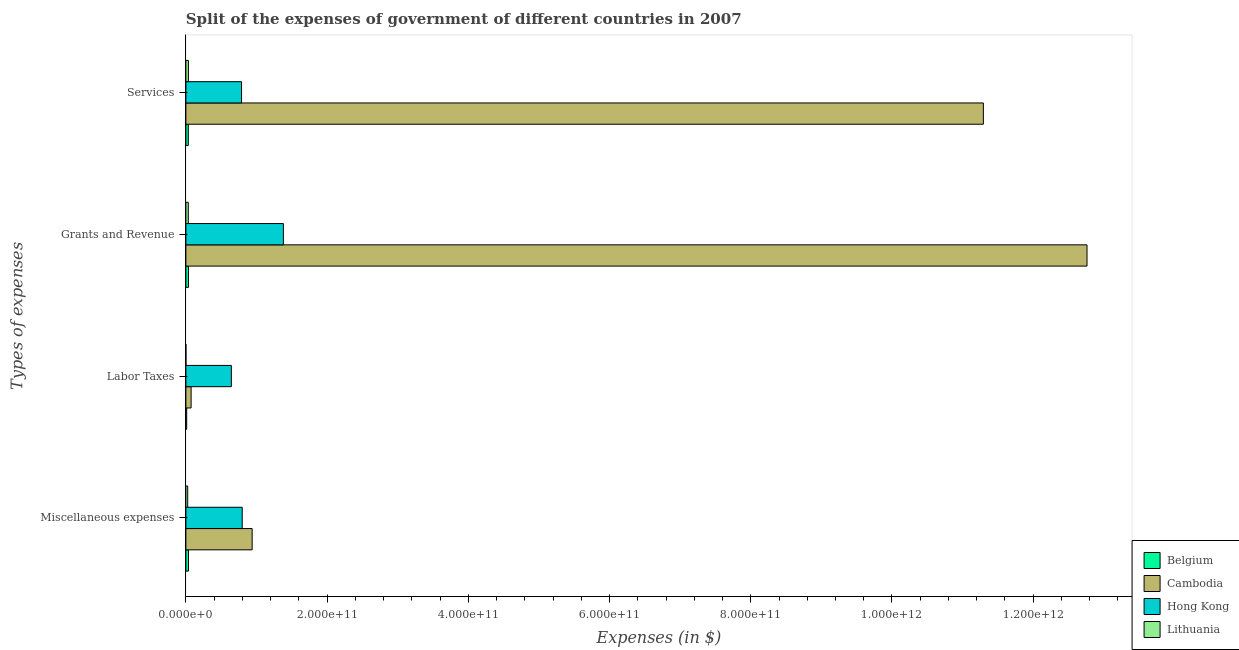How many different coloured bars are there?
Your response must be concise. 4. How many groups of bars are there?
Offer a terse response. 4. Are the number of bars per tick equal to the number of legend labels?
Provide a succinct answer. Yes. Are the number of bars on each tick of the Y-axis equal?
Ensure brevity in your answer.  Yes. How many bars are there on the 1st tick from the bottom?
Keep it short and to the point. 4. What is the label of the 4th group of bars from the top?
Offer a terse response. Miscellaneous expenses. What is the amount spent on services in Belgium?
Keep it short and to the point. 3.44e+09. Across all countries, what is the maximum amount spent on grants and revenue?
Your answer should be compact. 1.28e+12. Across all countries, what is the minimum amount spent on grants and revenue?
Give a very brief answer. 3.42e+09. In which country was the amount spent on miscellaneous expenses maximum?
Keep it short and to the point. Cambodia. What is the total amount spent on miscellaneous expenses in the graph?
Provide a short and direct response. 1.80e+11. What is the difference between the amount spent on labor taxes in Lithuania and that in Cambodia?
Offer a terse response. -7.38e+09. What is the difference between the amount spent on miscellaneous expenses in Lithuania and the amount spent on labor taxes in Hong Kong?
Keep it short and to the point. -6.18e+1. What is the average amount spent on services per country?
Give a very brief answer. 3.04e+11. What is the difference between the amount spent on services and amount spent on grants and revenue in Hong Kong?
Your answer should be compact. -5.93e+1. In how many countries, is the amount spent on services greater than 960000000000 $?
Provide a succinct answer. 1. What is the ratio of the amount spent on miscellaneous expenses in Cambodia to that in Belgium?
Offer a very short reply. 25.39. What is the difference between the highest and the second highest amount spent on miscellaneous expenses?
Your answer should be very brief. 1.41e+1. What is the difference between the highest and the lowest amount spent on labor taxes?
Your answer should be very brief. 6.44e+1. Is the sum of the amount spent on grants and revenue in Lithuania and Hong Kong greater than the maximum amount spent on services across all countries?
Keep it short and to the point. No. How many bars are there?
Your answer should be compact. 16. Are all the bars in the graph horizontal?
Provide a succinct answer. Yes. How many countries are there in the graph?
Your answer should be compact. 4. What is the difference between two consecutive major ticks on the X-axis?
Your response must be concise. 2.00e+11. Does the graph contain grids?
Provide a succinct answer. No. How many legend labels are there?
Your response must be concise. 4. What is the title of the graph?
Your response must be concise. Split of the expenses of government of different countries in 2007. Does "Turks and Caicos Islands" appear as one of the legend labels in the graph?
Make the answer very short. No. What is the label or title of the X-axis?
Give a very brief answer. Expenses (in $). What is the label or title of the Y-axis?
Ensure brevity in your answer.  Types of expenses. What is the Expenses (in $) in Belgium in Miscellaneous expenses?
Your response must be concise. 3.70e+09. What is the Expenses (in $) in Cambodia in Miscellaneous expenses?
Your answer should be compact. 9.39e+1. What is the Expenses (in $) in Hong Kong in Miscellaneous expenses?
Your answer should be compact. 7.98e+1. What is the Expenses (in $) of Lithuania in Miscellaneous expenses?
Provide a short and direct response. 2.58e+09. What is the Expenses (in $) in Belgium in Labor Taxes?
Keep it short and to the point. 1.15e+09. What is the Expenses (in $) in Cambodia in Labor Taxes?
Give a very brief answer. 7.42e+09. What is the Expenses (in $) of Hong Kong in Labor Taxes?
Make the answer very short. 6.44e+1. What is the Expenses (in $) in Lithuania in Labor Taxes?
Your answer should be compact. 3.97e+07. What is the Expenses (in $) in Belgium in Grants and Revenue?
Your answer should be compact. 3.64e+09. What is the Expenses (in $) in Cambodia in Grants and Revenue?
Your answer should be very brief. 1.28e+12. What is the Expenses (in $) in Hong Kong in Grants and Revenue?
Offer a terse response. 1.38e+11. What is the Expenses (in $) in Lithuania in Grants and Revenue?
Your answer should be very brief. 3.42e+09. What is the Expenses (in $) of Belgium in Services?
Your answer should be compact. 3.44e+09. What is the Expenses (in $) in Cambodia in Services?
Make the answer very short. 1.13e+12. What is the Expenses (in $) in Hong Kong in Services?
Provide a succinct answer. 7.88e+1. What is the Expenses (in $) of Lithuania in Services?
Provide a succinct answer. 3.58e+09. Across all Types of expenses, what is the maximum Expenses (in $) in Belgium?
Your response must be concise. 3.70e+09. Across all Types of expenses, what is the maximum Expenses (in $) of Cambodia?
Make the answer very short. 1.28e+12. Across all Types of expenses, what is the maximum Expenses (in $) of Hong Kong?
Ensure brevity in your answer.  1.38e+11. Across all Types of expenses, what is the maximum Expenses (in $) of Lithuania?
Ensure brevity in your answer.  3.58e+09. Across all Types of expenses, what is the minimum Expenses (in $) of Belgium?
Offer a terse response. 1.15e+09. Across all Types of expenses, what is the minimum Expenses (in $) of Cambodia?
Provide a succinct answer. 7.42e+09. Across all Types of expenses, what is the minimum Expenses (in $) of Hong Kong?
Your answer should be compact. 6.44e+1. Across all Types of expenses, what is the minimum Expenses (in $) in Lithuania?
Your answer should be very brief. 3.97e+07. What is the total Expenses (in $) of Belgium in the graph?
Keep it short and to the point. 1.19e+1. What is the total Expenses (in $) in Cambodia in the graph?
Your answer should be compact. 2.51e+12. What is the total Expenses (in $) of Hong Kong in the graph?
Make the answer very short. 3.61e+11. What is the total Expenses (in $) in Lithuania in the graph?
Provide a short and direct response. 9.62e+09. What is the difference between the Expenses (in $) of Belgium in Miscellaneous expenses and that in Labor Taxes?
Keep it short and to the point. 2.54e+09. What is the difference between the Expenses (in $) of Cambodia in Miscellaneous expenses and that in Labor Taxes?
Ensure brevity in your answer.  8.64e+1. What is the difference between the Expenses (in $) of Hong Kong in Miscellaneous expenses and that in Labor Taxes?
Your answer should be very brief. 1.54e+1. What is the difference between the Expenses (in $) in Lithuania in Miscellaneous expenses and that in Labor Taxes?
Offer a very short reply. 2.54e+09. What is the difference between the Expenses (in $) in Belgium in Miscellaneous expenses and that in Grants and Revenue?
Ensure brevity in your answer.  5.42e+07. What is the difference between the Expenses (in $) in Cambodia in Miscellaneous expenses and that in Grants and Revenue?
Provide a succinct answer. -1.18e+12. What is the difference between the Expenses (in $) in Hong Kong in Miscellaneous expenses and that in Grants and Revenue?
Give a very brief answer. -5.83e+1. What is the difference between the Expenses (in $) of Lithuania in Miscellaneous expenses and that in Grants and Revenue?
Make the answer very short. -8.37e+08. What is the difference between the Expenses (in $) in Belgium in Miscellaneous expenses and that in Services?
Provide a short and direct response. 2.58e+08. What is the difference between the Expenses (in $) of Cambodia in Miscellaneous expenses and that in Services?
Your answer should be very brief. -1.04e+12. What is the difference between the Expenses (in $) in Hong Kong in Miscellaneous expenses and that in Services?
Provide a short and direct response. 9.52e+08. What is the difference between the Expenses (in $) of Lithuania in Miscellaneous expenses and that in Services?
Your answer should be very brief. -9.99e+08. What is the difference between the Expenses (in $) of Belgium in Labor Taxes and that in Grants and Revenue?
Ensure brevity in your answer.  -2.49e+09. What is the difference between the Expenses (in $) of Cambodia in Labor Taxes and that in Grants and Revenue?
Your response must be concise. -1.27e+12. What is the difference between the Expenses (in $) in Hong Kong in Labor Taxes and that in Grants and Revenue?
Your response must be concise. -7.37e+1. What is the difference between the Expenses (in $) of Lithuania in Labor Taxes and that in Grants and Revenue?
Offer a very short reply. -3.38e+09. What is the difference between the Expenses (in $) in Belgium in Labor Taxes and that in Services?
Provide a succinct answer. -2.28e+09. What is the difference between the Expenses (in $) in Cambodia in Labor Taxes and that in Services?
Ensure brevity in your answer.  -1.12e+12. What is the difference between the Expenses (in $) in Hong Kong in Labor Taxes and that in Services?
Keep it short and to the point. -1.44e+1. What is the difference between the Expenses (in $) in Lithuania in Labor Taxes and that in Services?
Your response must be concise. -3.54e+09. What is the difference between the Expenses (in $) of Belgium in Grants and Revenue and that in Services?
Your answer should be very brief. 2.04e+08. What is the difference between the Expenses (in $) of Cambodia in Grants and Revenue and that in Services?
Provide a short and direct response. 1.47e+11. What is the difference between the Expenses (in $) of Hong Kong in Grants and Revenue and that in Services?
Keep it short and to the point. 5.93e+1. What is the difference between the Expenses (in $) of Lithuania in Grants and Revenue and that in Services?
Ensure brevity in your answer.  -1.62e+08. What is the difference between the Expenses (in $) of Belgium in Miscellaneous expenses and the Expenses (in $) of Cambodia in Labor Taxes?
Provide a short and direct response. -3.72e+09. What is the difference between the Expenses (in $) of Belgium in Miscellaneous expenses and the Expenses (in $) of Hong Kong in Labor Taxes?
Make the answer very short. -6.07e+1. What is the difference between the Expenses (in $) in Belgium in Miscellaneous expenses and the Expenses (in $) in Lithuania in Labor Taxes?
Keep it short and to the point. 3.66e+09. What is the difference between the Expenses (in $) of Cambodia in Miscellaneous expenses and the Expenses (in $) of Hong Kong in Labor Taxes?
Keep it short and to the point. 2.95e+1. What is the difference between the Expenses (in $) of Cambodia in Miscellaneous expenses and the Expenses (in $) of Lithuania in Labor Taxes?
Keep it short and to the point. 9.38e+1. What is the difference between the Expenses (in $) of Hong Kong in Miscellaneous expenses and the Expenses (in $) of Lithuania in Labor Taxes?
Make the answer very short. 7.97e+1. What is the difference between the Expenses (in $) of Belgium in Miscellaneous expenses and the Expenses (in $) of Cambodia in Grants and Revenue?
Offer a very short reply. -1.27e+12. What is the difference between the Expenses (in $) of Belgium in Miscellaneous expenses and the Expenses (in $) of Hong Kong in Grants and Revenue?
Provide a succinct answer. -1.34e+11. What is the difference between the Expenses (in $) in Belgium in Miscellaneous expenses and the Expenses (in $) in Lithuania in Grants and Revenue?
Provide a short and direct response. 2.77e+08. What is the difference between the Expenses (in $) in Cambodia in Miscellaneous expenses and the Expenses (in $) in Hong Kong in Grants and Revenue?
Your response must be concise. -4.42e+1. What is the difference between the Expenses (in $) in Cambodia in Miscellaneous expenses and the Expenses (in $) in Lithuania in Grants and Revenue?
Your response must be concise. 9.04e+1. What is the difference between the Expenses (in $) in Hong Kong in Miscellaneous expenses and the Expenses (in $) in Lithuania in Grants and Revenue?
Ensure brevity in your answer.  7.64e+1. What is the difference between the Expenses (in $) in Belgium in Miscellaneous expenses and the Expenses (in $) in Cambodia in Services?
Offer a terse response. -1.13e+12. What is the difference between the Expenses (in $) of Belgium in Miscellaneous expenses and the Expenses (in $) of Hong Kong in Services?
Keep it short and to the point. -7.51e+1. What is the difference between the Expenses (in $) in Belgium in Miscellaneous expenses and the Expenses (in $) in Lithuania in Services?
Keep it short and to the point. 1.14e+08. What is the difference between the Expenses (in $) in Cambodia in Miscellaneous expenses and the Expenses (in $) in Hong Kong in Services?
Keep it short and to the point. 1.50e+1. What is the difference between the Expenses (in $) in Cambodia in Miscellaneous expenses and the Expenses (in $) in Lithuania in Services?
Provide a succinct answer. 9.03e+1. What is the difference between the Expenses (in $) in Hong Kong in Miscellaneous expenses and the Expenses (in $) in Lithuania in Services?
Offer a very short reply. 7.62e+1. What is the difference between the Expenses (in $) of Belgium in Labor Taxes and the Expenses (in $) of Cambodia in Grants and Revenue?
Your response must be concise. -1.28e+12. What is the difference between the Expenses (in $) in Belgium in Labor Taxes and the Expenses (in $) in Hong Kong in Grants and Revenue?
Your answer should be very brief. -1.37e+11. What is the difference between the Expenses (in $) in Belgium in Labor Taxes and the Expenses (in $) in Lithuania in Grants and Revenue?
Ensure brevity in your answer.  -2.27e+09. What is the difference between the Expenses (in $) of Cambodia in Labor Taxes and the Expenses (in $) of Hong Kong in Grants and Revenue?
Your answer should be compact. -1.31e+11. What is the difference between the Expenses (in $) of Cambodia in Labor Taxes and the Expenses (in $) of Lithuania in Grants and Revenue?
Make the answer very short. 4.00e+09. What is the difference between the Expenses (in $) in Hong Kong in Labor Taxes and the Expenses (in $) in Lithuania in Grants and Revenue?
Offer a very short reply. 6.10e+1. What is the difference between the Expenses (in $) in Belgium in Labor Taxes and the Expenses (in $) in Cambodia in Services?
Provide a succinct answer. -1.13e+12. What is the difference between the Expenses (in $) of Belgium in Labor Taxes and the Expenses (in $) of Hong Kong in Services?
Offer a terse response. -7.77e+1. What is the difference between the Expenses (in $) in Belgium in Labor Taxes and the Expenses (in $) in Lithuania in Services?
Offer a very short reply. -2.43e+09. What is the difference between the Expenses (in $) of Cambodia in Labor Taxes and the Expenses (in $) of Hong Kong in Services?
Offer a terse response. -7.14e+1. What is the difference between the Expenses (in $) of Cambodia in Labor Taxes and the Expenses (in $) of Lithuania in Services?
Give a very brief answer. 3.83e+09. What is the difference between the Expenses (in $) in Hong Kong in Labor Taxes and the Expenses (in $) in Lithuania in Services?
Your response must be concise. 6.08e+1. What is the difference between the Expenses (in $) in Belgium in Grants and Revenue and the Expenses (in $) in Cambodia in Services?
Provide a succinct answer. -1.13e+12. What is the difference between the Expenses (in $) in Belgium in Grants and Revenue and the Expenses (in $) in Hong Kong in Services?
Provide a succinct answer. -7.52e+1. What is the difference between the Expenses (in $) in Belgium in Grants and Revenue and the Expenses (in $) in Lithuania in Services?
Offer a terse response. 6.00e+07. What is the difference between the Expenses (in $) in Cambodia in Grants and Revenue and the Expenses (in $) in Hong Kong in Services?
Keep it short and to the point. 1.20e+12. What is the difference between the Expenses (in $) of Cambodia in Grants and Revenue and the Expenses (in $) of Lithuania in Services?
Provide a succinct answer. 1.27e+12. What is the difference between the Expenses (in $) of Hong Kong in Grants and Revenue and the Expenses (in $) of Lithuania in Services?
Keep it short and to the point. 1.35e+11. What is the average Expenses (in $) in Belgium per Types of expenses?
Keep it short and to the point. 2.98e+09. What is the average Expenses (in $) of Cambodia per Types of expenses?
Provide a succinct answer. 6.27e+11. What is the average Expenses (in $) in Hong Kong per Types of expenses?
Keep it short and to the point. 9.03e+1. What is the average Expenses (in $) in Lithuania per Types of expenses?
Give a very brief answer. 2.41e+09. What is the difference between the Expenses (in $) in Belgium and Expenses (in $) in Cambodia in Miscellaneous expenses?
Your answer should be compact. -9.02e+1. What is the difference between the Expenses (in $) in Belgium and Expenses (in $) in Hong Kong in Miscellaneous expenses?
Give a very brief answer. -7.61e+1. What is the difference between the Expenses (in $) in Belgium and Expenses (in $) in Lithuania in Miscellaneous expenses?
Provide a succinct answer. 1.11e+09. What is the difference between the Expenses (in $) in Cambodia and Expenses (in $) in Hong Kong in Miscellaneous expenses?
Offer a terse response. 1.41e+1. What is the difference between the Expenses (in $) of Cambodia and Expenses (in $) of Lithuania in Miscellaneous expenses?
Provide a succinct answer. 9.13e+1. What is the difference between the Expenses (in $) of Hong Kong and Expenses (in $) of Lithuania in Miscellaneous expenses?
Your answer should be compact. 7.72e+1. What is the difference between the Expenses (in $) of Belgium and Expenses (in $) of Cambodia in Labor Taxes?
Your answer should be very brief. -6.26e+09. What is the difference between the Expenses (in $) of Belgium and Expenses (in $) of Hong Kong in Labor Taxes?
Keep it short and to the point. -6.32e+1. What is the difference between the Expenses (in $) in Belgium and Expenses (in $) in Lithuania in Labor Taxes?
Provide a succinct answer. 1.11e+09. What is the difference between the Expenses (in $) of Cambodia and Expenses (in $) of Hong Kong in Labor Taxes?
Keep it short and to the point. -5.70e+1. What is the difference between the Expenses (in $) of Cambodia and Expenses (in $) of Lithuania in Labor Taxes?
Your response must be concise. 7.38e+09. What is the difference between the Expenses (in $) in Hong Kong and Expenses (in $) in Lithuania in Labor Taxes?
Offer a terse response. 6.44e+1. What is the difference between the Expenses (in $) in Belgium and Expenses (in $) in Cambodia in Grants and Revenue?
Your answer should be compact. -1.27e+12. What is the difference between the Expenses (in $) of Belgium and Expenses (in $) of Hong Kong in Grants and Revenue?
Ensure brevity in your answer.  -1.34e+11. What is the difference between the Expenses (in $) of Belgium and Expenses (in $) of Lithuania in Grants and Revenue?
Provide a short and direct response. 2.22e+08. What is the difference between the Expenses (in $) of Cambodia and Expenses (in $) of Hong Kong in Grants and Revenue?
Offer a very short reply. 1.14e+12. What is the difference between the Expenses (in $) of Cambodia and Expenses (in $) of Lithuania in Grants and Revenue?
Make the answer very short. 1.27e+12. What is the difference between the Expenses (in $) in Hong Kong and Expenses (in $) in Lithuania in Grants and Revenue?
Offer a very short reply. 1.35e+11. What is the difference between the Expenses (in $) of Belgium and Expenses (in $) of Cambodia in Services?
Keep it short and to the point. -1.13e+12. What is the difference between the Expenses (in $) of Belgium and Expenses (in $) of Hong Kong in Services?
Your answer should be compact. -7.54e+1. What is the difference between the Expenses (in $) in Belgium and Expenses (in $) in Lithuania in Services?
Give a very brief answer. -1.44e+08. What is the difference between the Expenses (in $) in Cambodia and Expenses (in $) in Hong Kong in Services?
Make the answer very short. 1.05e+12. What is the difference between the Expenses (in $) of Cambodia and Expenses (in $) of Lithuania in Services?
Your answer should be very brief. 1.13e+12. What is the difference between the Expenses (in $) of Hong Kong and Expenses (in $) of Lithuania in Services?
Your response must be concise. 7.52e+1. What is the ratio of the Expenses (in $) of Belgium in Miscellaneous expenses to that in Labor Taxes?
Your response must be concise. 3.2. What is the ratio of the Expenses (in $) in Cambodia in Miscellaneous expenses to that in Labor Taxes?
Provide a succinct answer. 12.66. What is the ratio of the Expenses (in $) of Hong Kong in Miscellaneous expenses to that in Labor Taxes?
Give a very brief answer. 1.24. What is the ratio of the Expenses (in $) of Lithuania in Miscellaneous expenses to that in Labor Taxes?
Your answer should be very brief. 65.06. What is the ratio of the Expenses (in $) in Belgium in Miscellaneous expenses to that in Grants and Revenue?
Give a very brief answer. 1.01. What is the ratio of the Expenses (in $) of Cambodia in Miscellaneous expenses to that in Grants and Revenue?
Provide a short and direct response. 0.07. What is the ratio of the Expenses (in $) of Hong Kong in Miscellaneous expenses to that in Grants and Revenue?
Your answer should be compact. 0.58. What is the ratio of the Expenses (in $) of Lithuania in Miscellaneous expenses to that in Grants and Revenue?
Ensure brevity in your answer.  0.76. What is the ratio of the Expenses (in $) of Belgium in Miscellaneous expenses to that in Services?
Ensure brevity in your answer.  1.08. What is the ratio of the Expenses (in $) of Cambodia in Miscellaneous expenses to that in Services?
Provide a short and direct response. 0.08. What is the ratio of the Expenses (in $) of Hong Kong in Miscellaneous expenses to that in Services?
Ensure brevity in your answer.  1.01. What is the ratio of the Expenses (in $) in Lithuania in Miscellaneous expenses to that in Services?
Make the answer very short. 0.72. What is the ratio of the Expenses (in $) of Belgium in Labor Taxes to that in Grants and Revenue?
Ensure brevity in your answer.  0.32. What is the ratio of the Expenses (in $) of Cambodia in Labor Taxes to that in Grants and Revenue?
Your response must be concise. 0.01. What is the ratio of the Expenses (in $) of Hong Kong in Labor Taxes to that in Grants and Revenue?
Keep it short and to the point. 0.47. What is the ratio of the Expenses (in $) in Lithuania in Labor Taxes to that in Grants and Revenue?
Offer a terse response. 0.01. What is the ratio of the Expenses (in $) in Belgium in Labor Taxes to that in Services?
Provide a succinct answer. 0.34. What is the ratio of the Expenses (in $) in Cambodia in Labor Taxes to that in Services?
Your answer should be compact. 0.01. What is the ratio of the Expenses (in $) of Hong Kong in Labor Taxes to that in Services?
Offer a terse response. 0.82. What is the ratio of the Expenses (in $) of Lithuania in Labor Taxes to that in Services?
Provide a short and direct response. 0.01. What is the ratio of the Expenses (in $) of Belgium in Grants and Revenue to that in Services?
Make the answer very short. 1.06. What is the ratio of the Expenses (in $) of Cambodia in Grants and Revenue to that in Services?
Provide a short and direct response. 1.13. What is the ratio of the Expenses (in $) of Hong Kong in Grants and Revenue to that in Services?
Offer a very short reply. 1.75. What is the ratio of the Expenses (in $) of Lithuania in Grants and Revenue to that in Services?
Offer a very short reply. 0.95. What is the difference between the highest and the second highest Expenses (in $) in Belgium?
Provide a succinct answer. 5.42e+07. What is the difference between the highest and the second highest Expenses (in $) of Cambodia?
Offer a very short reply. 1.47e+11. What is the difference between the highest and the second highest Expenses (in $) in Hong Kong?
Ensure brevity in your answer.  5.83e+1. What is the difference between the highest and the second highest Expenses (in $) in Lithuania?
Keep it short and to the point. 1.62e+08. What is the difference between the highest and the lowest Expenses (in $) in Belgium?
Make the answer very short. 2.54e+09. What is the difference between the highest and the lowest Expenses (in $) of Cambodia?
Your answer should be very brief. 1.27e+12. What is the difference between the highest and the lowest Expenses (in $) of Hong Kong?
Your answer should be very brief. 7.37e+1. What is the difference between the highest and the lowest Expenses (in $) of Lithuania?
Your answer should be compact. 3.54e+09. 